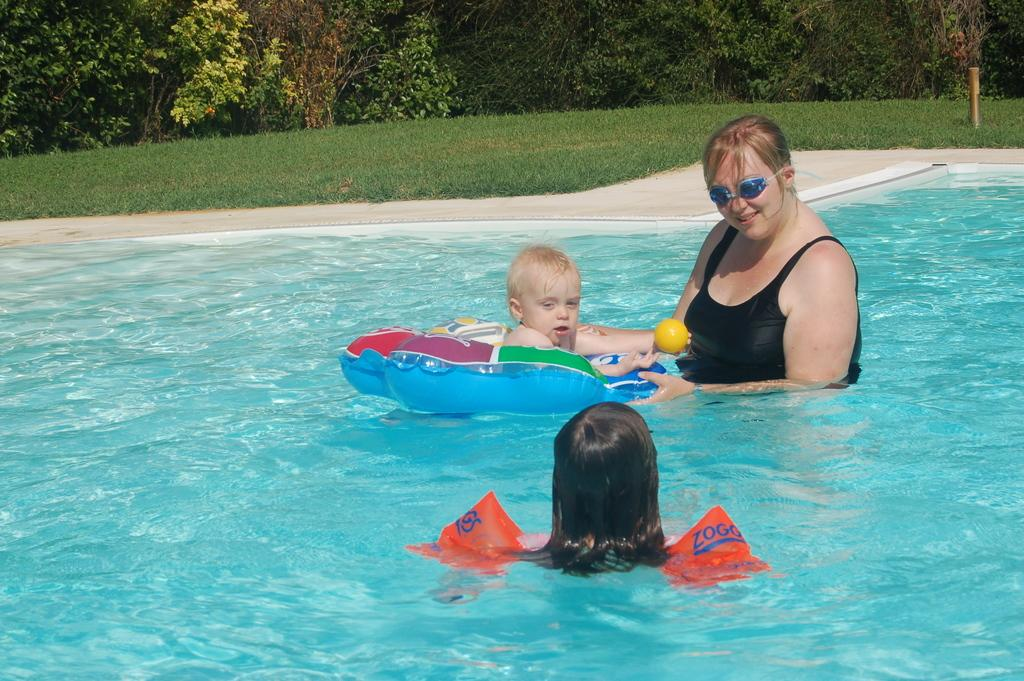What is the main feature in the center of the image? There is a swimming pool in the center of the image. Who is present in the swimming pool? A lady and two children are in the swimming pool. What can be seen at the top side of the image? There is greenery at the top side of the image. What type of kettle is being used for religious purposes in the image? There is no kettle or religious activity present in the image. Can you tell me how many crayons are being used by the children in the swimming pool? There are no crayons present in the image; the children are in a swimming pool. 